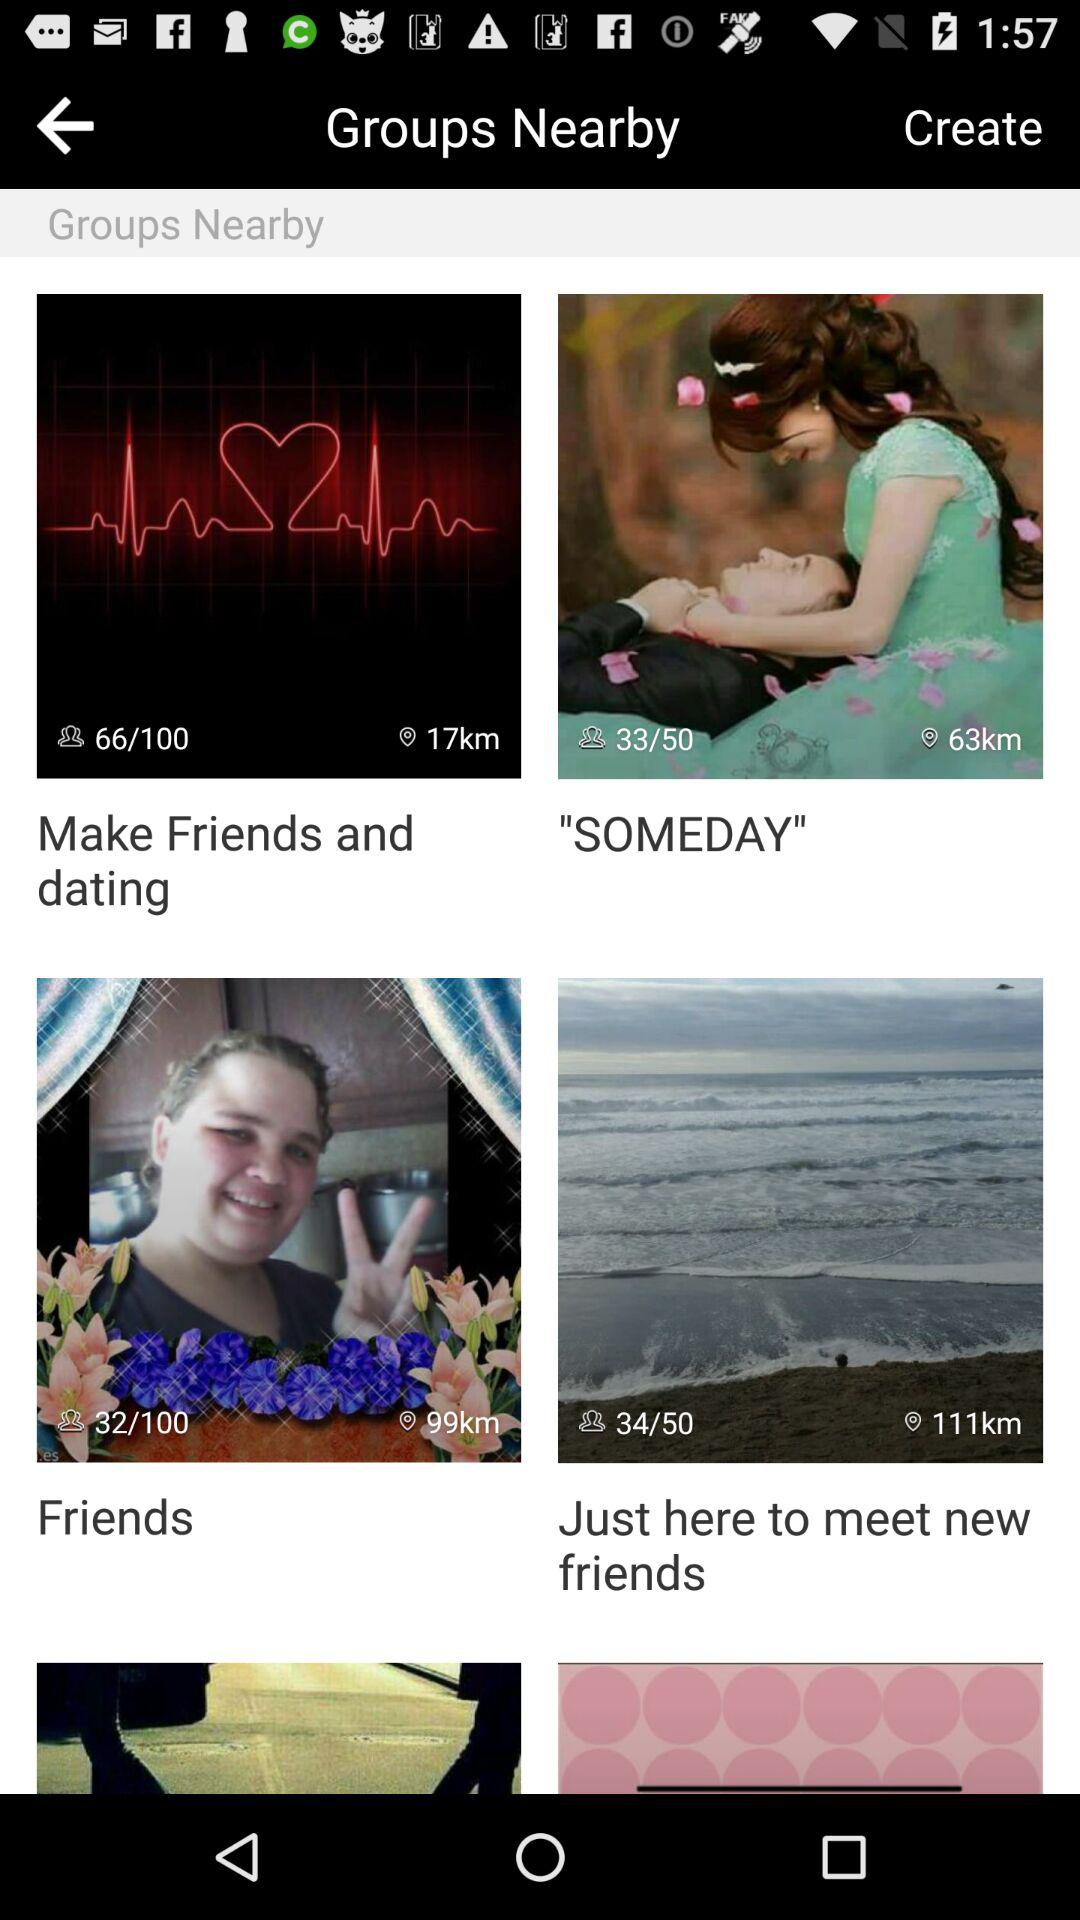What page number of "Friends" are we currently on? You are currently on page number 32 of "Friends". 